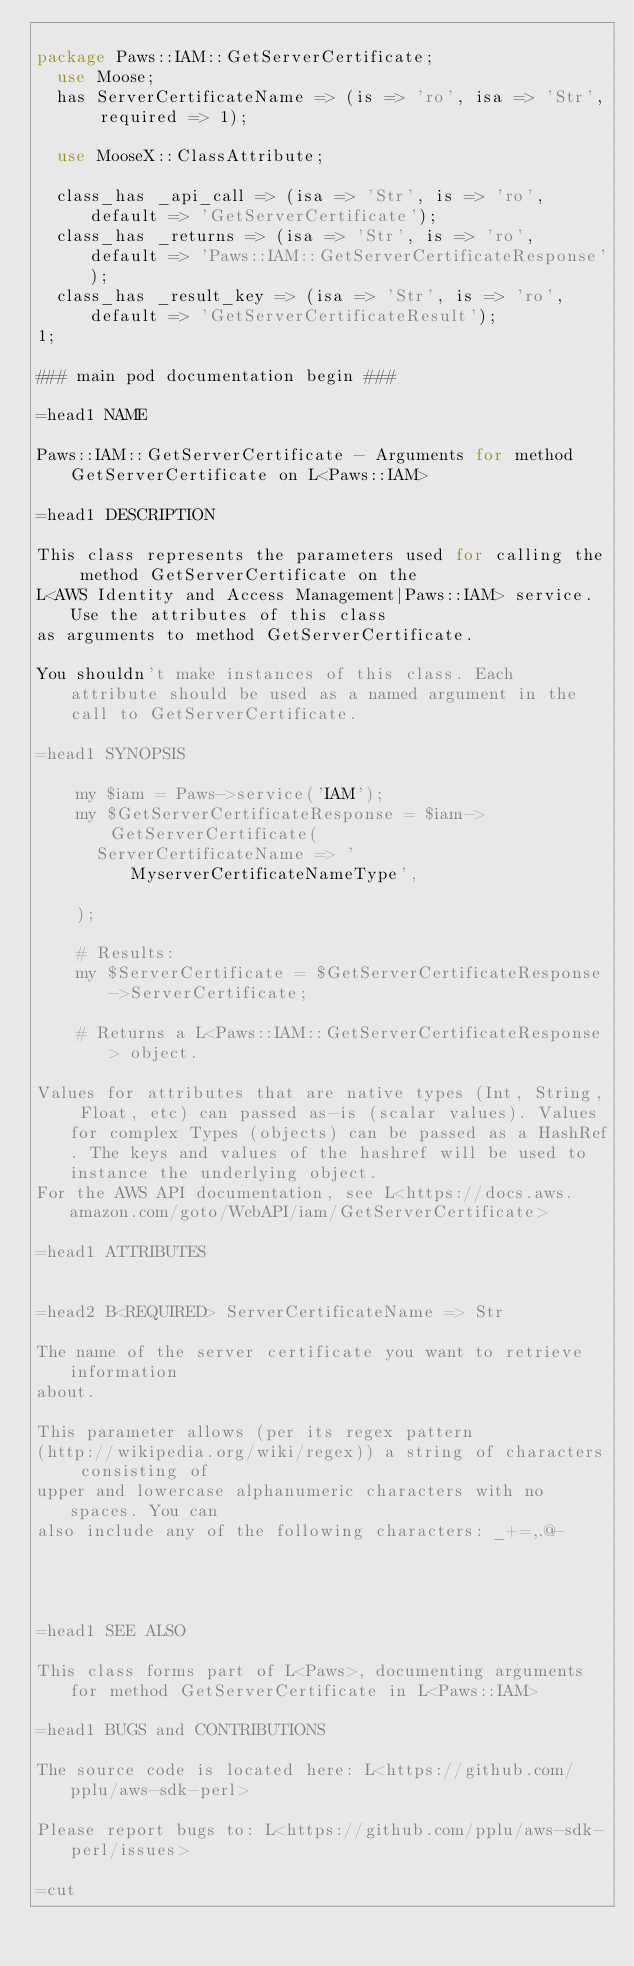<code> <loc_0><loc_0><loc_500><loc_500><_Perl_>
package Paws::IAM::GetServerCertificate;
  use Moose;
  has ServerCertificateName => (is => 'ro', isa => 'Str', required => 1);

  use MooseX::ClassAttribute;

  class_has _api_call => (isa => 'Str', is => 'ro', default => 'GetServerCertificate');
  class_has _returns => (isa => 'Str', is => 'ro', default => 'Paws::IAM::GetServerCertificateResponse');
  class_has _result_key => (isa => 'Str', is => 'ro', default => 'GetServerCertificateResult');
1;

### main pod documentation begin ###

=head1 NAME

Paws::IAM::GetServerCertificate - Arguments for method GetServerCertificate on L<Paws::IAM>

=head1 DESCRIPTION

This class represents the parameters used for calling the method GetServerCertificate on the
L<AWS Identity and Access Management|Paws::IAM> service. Use the attributes of this class
as arguments to method GetServerCertificate.

You shouldn't make instances of this class. Each attribute should be used as a named argument in the call to GetServerCertificate.

=head1 SYNOPSIS

    my $iam = Paws->service('IAM');
    my $GetServerCertificateResponse = $iam->GetServerCertificate(
      ServerCertificateName => 'MyserverCertificateNameType',

    );

    # Results:
    my $ServerCertificate = $GetServerCertificateResponse->ServerCertificate;

    # Returns a L<Paws::IAM::GetServerCertificateResponse> object.

Values for attributes that are native types (Int, String, Float, etc) can passed as-is (scalar values). Values for complex Types (objects) can be passed as a HashRef. The keys and values of the hashref will be used to instance the underlying object.
For the AWS API documentation, see L<https://docs.aws.amazon.com/goto/WebAPI/iam/GetServerCertificate>

=head1 ATTRIBUTES


=head2 B<REQUIRED> ServerCertificateName => Str

The name of the server certificate you want to retrieve information
about.

This parameter allows (per its regex pattern
(http://wikipedia.org/wiki/regex)) a string of characters consisting of
upper and lowercase alphanumeric characters with no spaces. You can
also include any of the following characters: _+=,.@-




=head1 SEE ALSO

This class forms part of L<Paws>, documenting arguments for method GetServerCertificate in L<Paws::IAM>

=head1 BUGS and CONTRIBUTIONS

The source code is located here: L<https://github.com/pplu/aws-sdk-perl>

Please report bugs to: L<https://github.com/pplu/aws-sdk-perl/issues>

=cut

</code> 